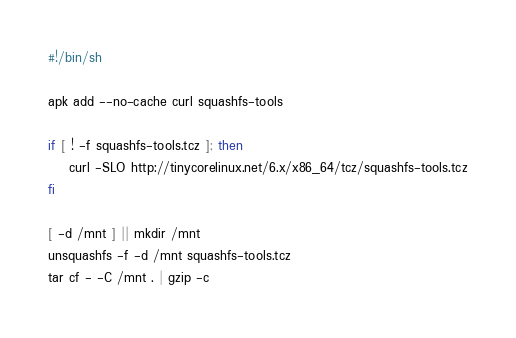<code> <loc_0><loc_0><loc_500><loc_500><_Bash_>#!/bin/sh

apk add --no-cache curl squashfs-tools

if [ ! -f squashfs-tools.tcz ]; then
    curl -SLO http://tinycorelinux.net/6.x/x86_64/tcz/squashfs-tools.tcz
fi

[ -d /mnt ] || mkdir /mnt
unsquashfs -f -d /mnt squashfs-tools.tcz
tar cf - -C /mnt . | gzip -c
</code> 